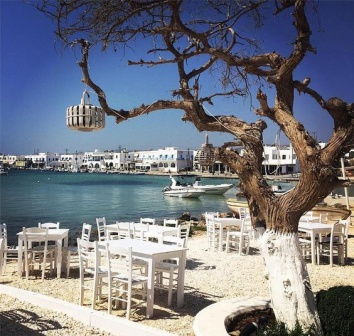Imagine a festival or special event taking place here. What kind of event would it be and how would the scene look? Imagine a local seafood festival taking place at this seaside restaurant. The entire patio is adorned with colorful banners and festoon lights. Stalls are set up around the perimeter, offering an array of seafood delicacies, artisanal cheeses, and local wines. A stage has been erected by the water's edge, where musicians perform lively folk songs. The air is filled with the enticing aroma of grilled fish, fresh paella, and sizzling shrimp skewers. Families and friends gather at the white tables, enjoying the feast and the festive atmosphere. Children run around, playing games and laughing with joy. The harbor is animated with additional boats bringing in fresh catches and participating in boat parades. As the sun sets, the scene becomes even more magical with the twinkling lights reflecting on the calm, turquoise waters, creating an unforgettable experience. 